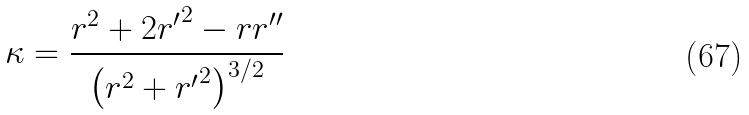Convert formula to latex. <formula><loc_0><loc_0><loc_500><loc_500>\kappa = { \frac { r ^ { 2 } + 2 { r ^ { \prime } } ^ { 2 } - r r ^ { \prime \prime } } { \left ( r ^ { 2 } + { r ^ { \prime } } ^ { 2 } \right ) ^ { 3 / 2 } } }</formula> 